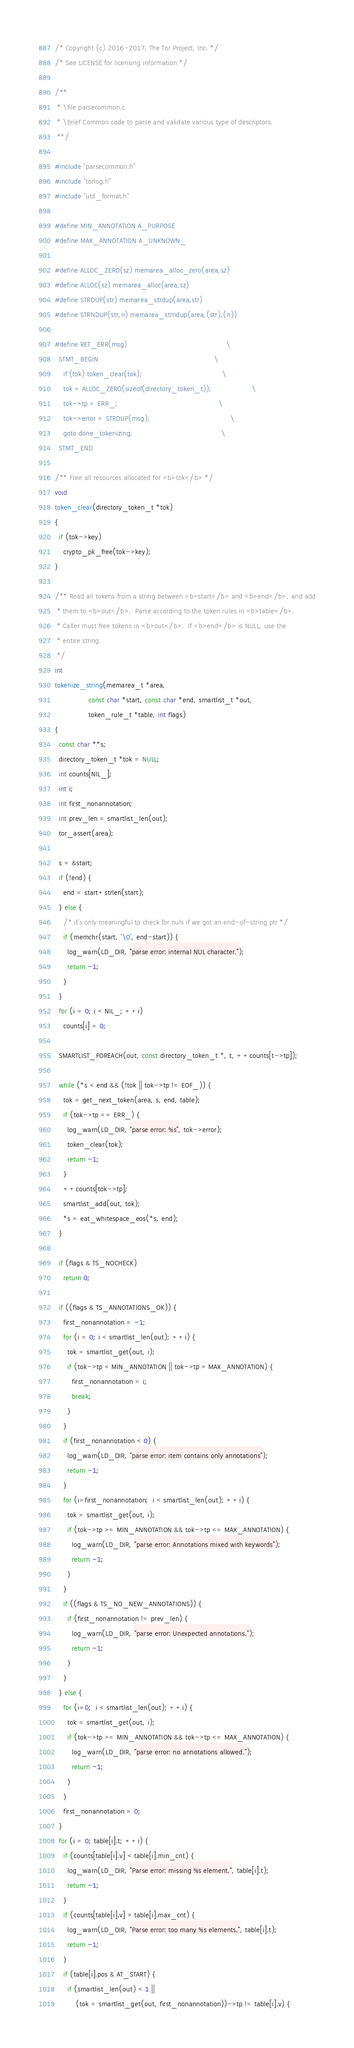Convert code to text. <code><loc_0><loc_0><loc_500><loc_500><_C_>/* Copyright (c) 2016-2017, The Tor Project, Inc. */
/* See LICENSE for licensing information */

/**
 * \file parsecommon.c
 * \brief Common code to parse and validate various type of descriptors.
 **/

#include "parsecommon.h"
#include "torlog.h"
#include "util_format.h"

#define MIN_ANNOTATION A_PURPOSE
#define MAX_ANNOTATION A_UNKNOWN_

#define ALLOC_ZERO(sz) memarea_alloc_zero(area,sz)
#define ALLOC(sz) memarea_alloc(area,sz)
#define STRDUP(str) memarea_strdup(area,str)
#define STRNDUP(str,n) memarea_strndup(area,(str),(n))

#define RET_ERR(msg)                                               \
  STMT_BEGIN                                                       \
    if (tok) token_clear(tok);                                      \
    tok = ALLOC_ZERO(sizeof(directory_token_t));                   \
    tok->tp = ERR_;                                                \
    tok->error = STRDUP(msg);                                      \
    goto done_tokenizing;                                          \
  STMT_END

/** Free all resources allocated for <b>tok</b> */
void
token_clear(directory_token_t *tok)
{
  if (tok->key)
    crypto_pk_free(tok->key);
}

/** Read all tokens from a string between <b>start</b> and <b>end</b>, and add
 * them to <b>out</b>.  Parse according to the token rules in <b>table</b>.
 * Caller must free tokens in <b>out</b>.  If <b>end</b> is NULL, use the
 * entire string.
 */
int
tokenize_string(memarea_t *area,
                const char *start, const char *end, smartlist_t *out,
                token_rule_t *table, int flags)
{
  const char **s;
  directory_token_t *tok = NULL;
  int counts[NIL_];
  int i;
  int first_nonannotation;
  int prev_len = smartlist_len(out);
  tor_assert(area);

  s = &start;
  if (!end) {
    end = start+strlen(start);
  } else {
    /* it's only meaningful to check for nuls if we got an end-of-string ptr */
    if (memchr(start, '\0', end-start)) {
      log_warn(LD_DIR, "parse error: internal NUL character.");
      return -1;
    }
  }
  for (i = 0; i < NIL_; ++i)
    counts[i] = 0;

  SMARTLIST_FOREACH(out, const directory_token_t *, t, ++counts[t->tp]);

  while (*s < end && (!tok || tok->tp != EOF_)) {
    tok = get_next_token(area, s, end, table);
    if (tok->tp == ERR_) {
      log_warn(LD_DIR, "parse error: %s", tok->error);
      token_clear(tok);
      return -1;
    }
    ++counts[tok->tp];
    smartlist_add(out, tok);
    *s = eat_whitespace_eos(*s, end);
  }

  if (flags & TS_NOCHECK)
    return 0;

  if ((flags & TS_ANNOTATIONS_OK)) {
    first_nonannotation = -1;
    for (i = 0; i < smartlist_len(out); ++i) {
      tok = smartlist_get(out, i);
      if (tok->tp < MIN_ANNOTATION || tok->tp > MAX_ANNOTATION) {
        first_nonannotation = i;
        break;
      }
    }
    if (first_nonannotation < 0) {
      log_warn(LD_DIR, "parse error: item contains only annotations");
      return -1;
    }
    for (i=first_nonannotation;  i < smartlist_len(out); ++i) {
      tok = smartlist_get(out, i);
      if (tok->tp >= MIN_ANNOTATION && tok->tp <= MAX_ANNOTATION) {
        log_warn(LD_DIR, "parse error: Annotations mixed with keywords");
        return -1;
      }
    }
    if ((flags & TS_NO_NEW_ANNOTATIONS)) {
      if (first_nonannotation != prev_len) {
        log_warn(LD_DIR, "parse error: Unexpected annotations.");
        return -1;
      }
    }
  } else {
    for (i=0;  i < smartlist_len(out); ++i) {
      tok = smartlist_get(out, i);
      if (tok->tp >= MIN_ANNOTATION && tok->tp <= MAX_ANNOTATION) {
        log_warn(LD_DIR, "parse error: no annotations allowed.");
        return -1;
      }
    }
    first_nonannotation = 0;
  }
  for (i = 0; table[i].t; ++i) {
    if (counts[table[i].v] < table[i].min_cnt) {
      log_warn(LD_DIR, "Parse error: missing %s element.", table[i].t);
      return -1;
    }
    if (counts[table[i].v] > table[i].max_cnt) {
      log_warn(LD_DIR, "Parse error: too many %s elements.", table[i].t);
      return -1;
    }
    if (table[i].pos & AT_START) {
      if (smartlist_len(out) < 1 ||
          (tok = smartlist_get(out, first_nonannotation))->tp != table[i].v) {</code> 